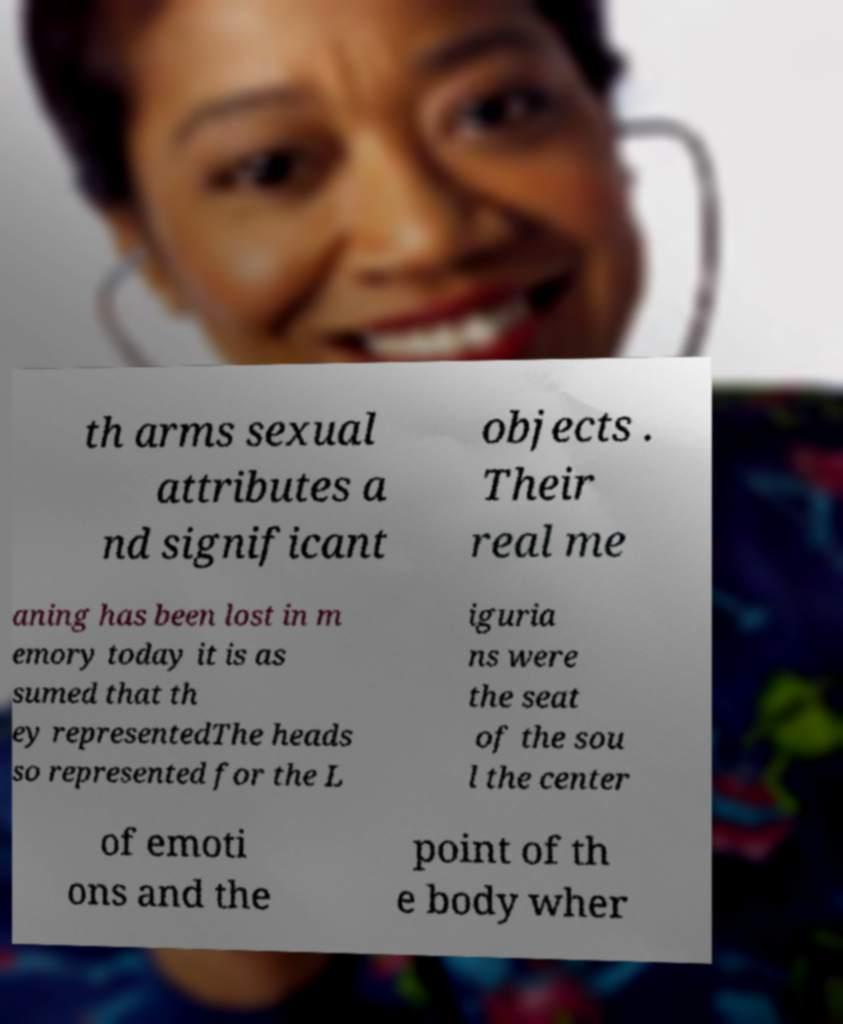Could you extract and type out the text from this image? th arms sexual attributes a nd significant objects . Their real me aning has been lost in m emory today it is as sumed that th ey representedThe heads so represented for the L iguria ns were the seat of the sou l the center of emoti ons and the point of th e body wher 